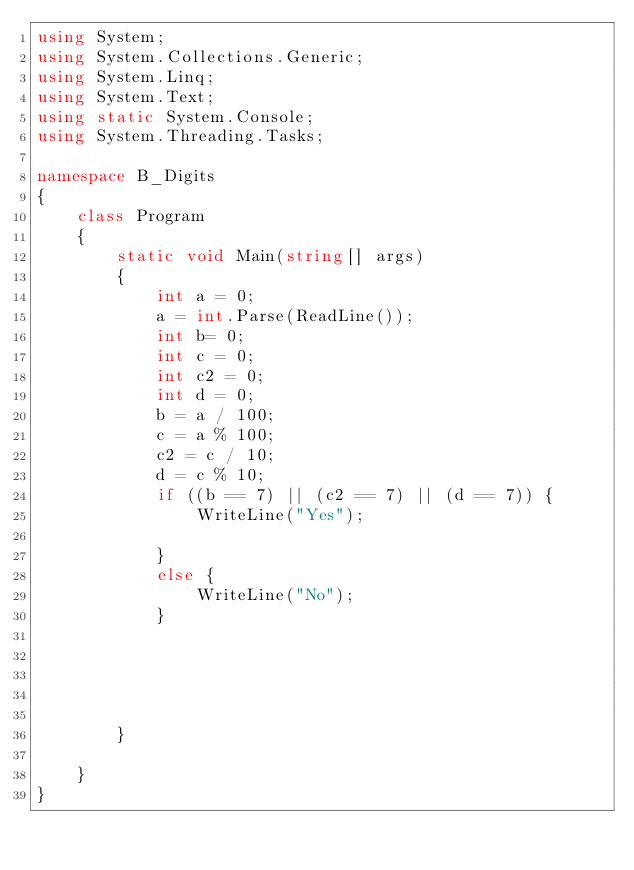<code> <loc_0><loc_0><loc_500><loc_500><_C#_>using System;
using System.Collections.Generic;
using System.Linq;
using System.Text;
using static System.Console;
using System.Threading.Tasks;

namespace B_Digits
{
    class Program
    {
        static void Main(string[] args)
        {
            int a = 0;
            a = int.Parse(ReadLine());
            int b= 0;
            int c = 0;
            int c2 = 0;
            int d = 0;
            b = a / 100;
            c = a % 100;
            c2 = c / 10;
            d = c % 10;
            if ((b == 7) || (c2 == 7) || (d == 7)) {
                WriteLine("Yes");

            }
            else {
                WriteLine("No");
            }
            




        }

    }
}


      
</code> 